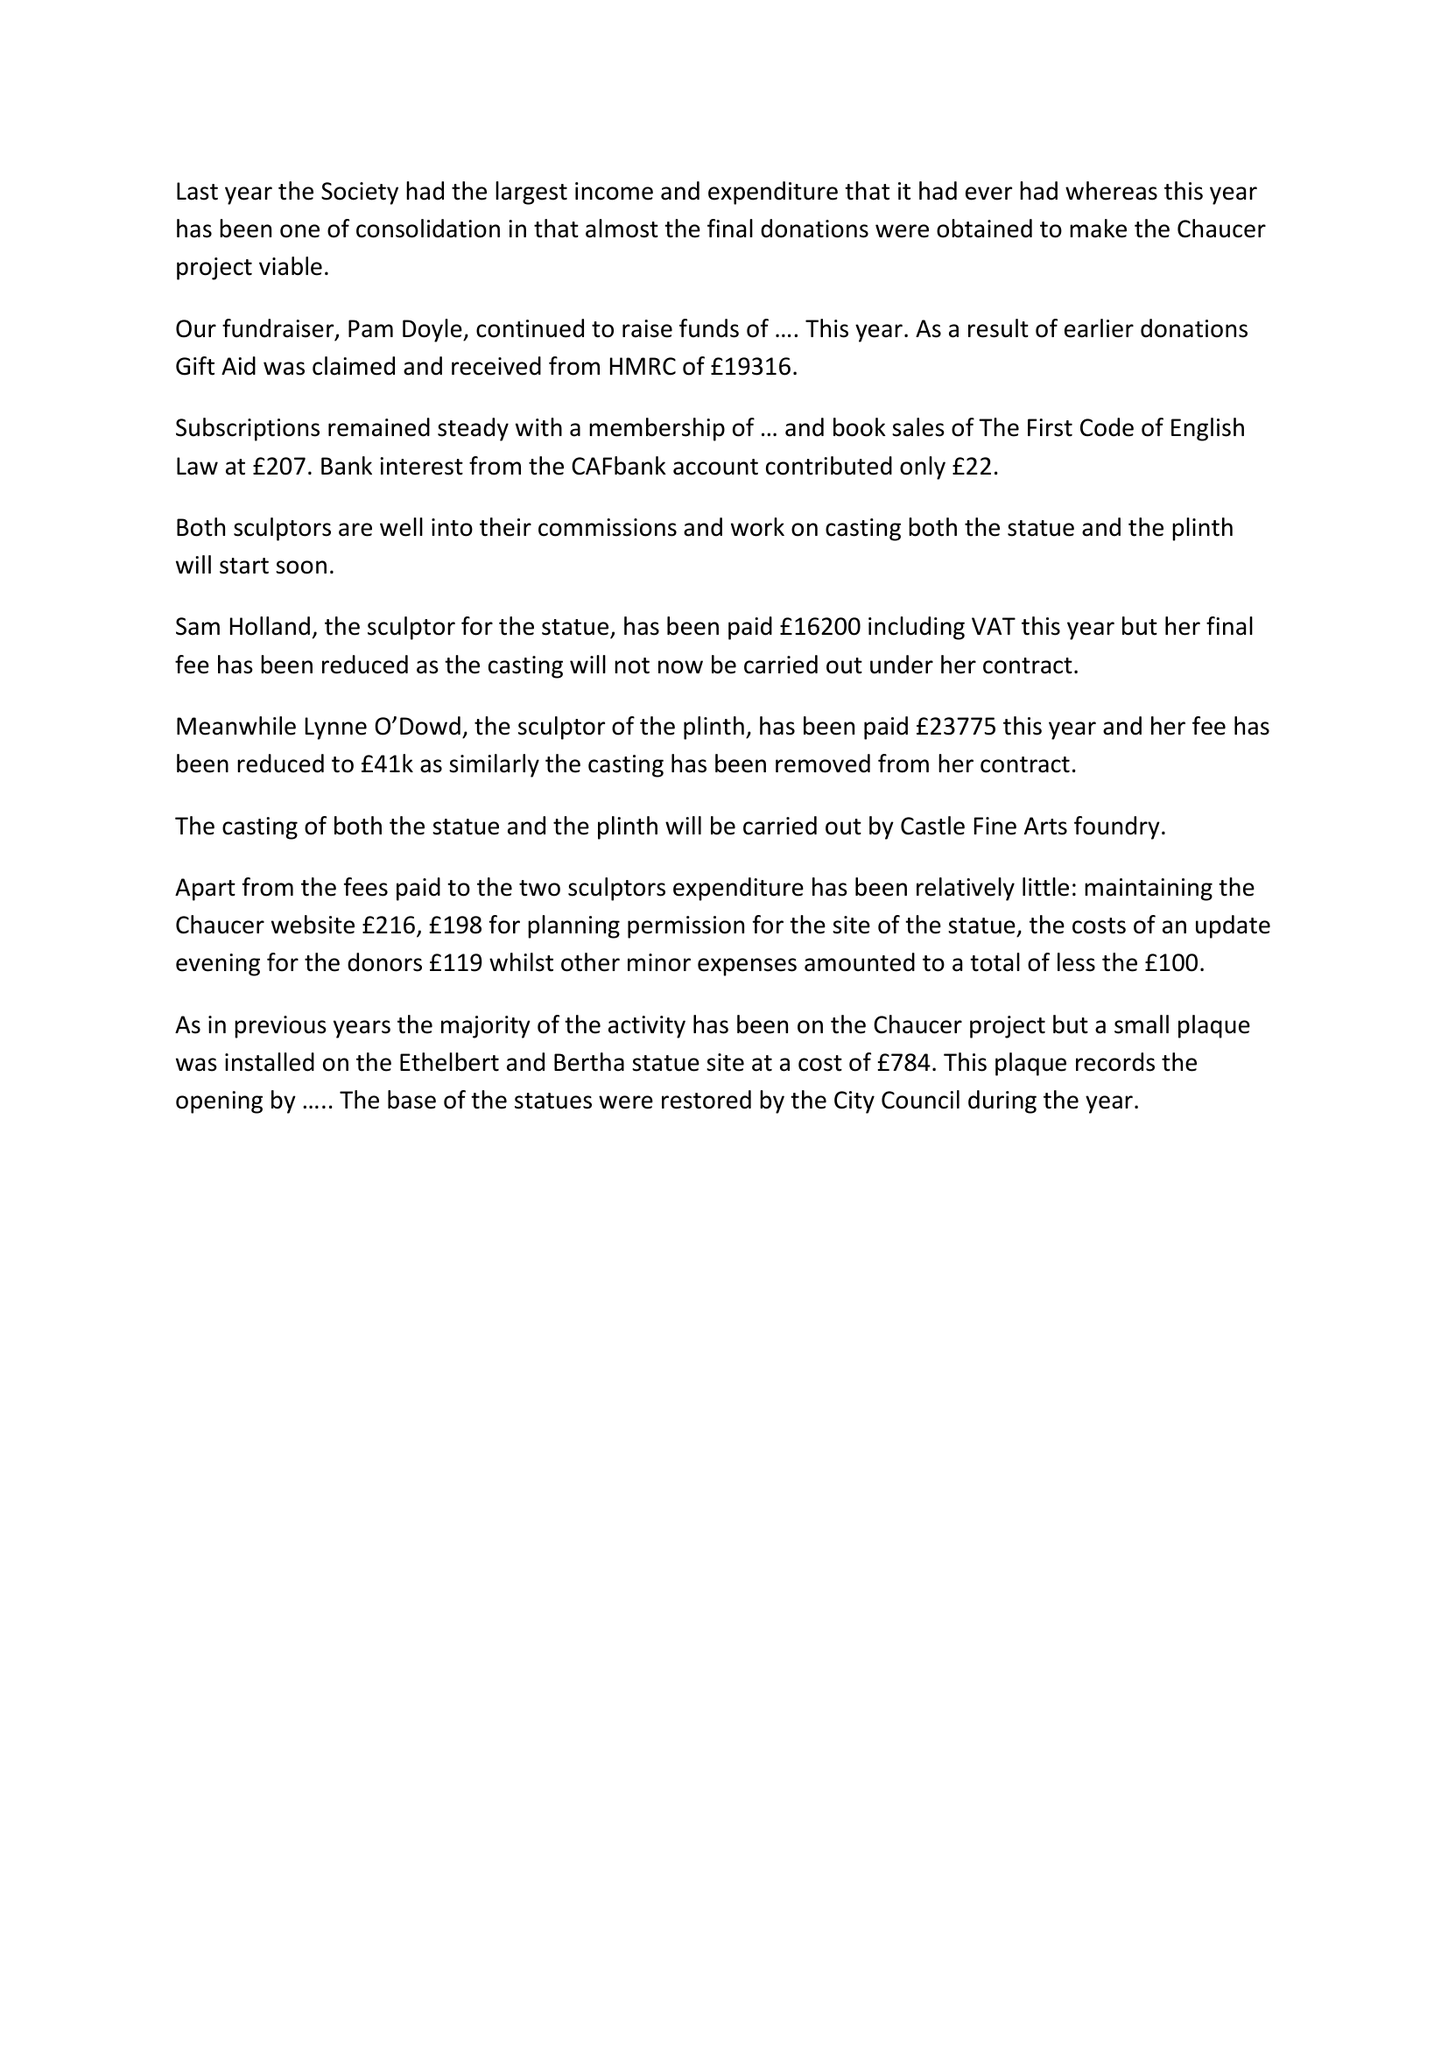What is the value for the spending_annually_in_british_pounds?
Answer the question using a single word or phrase. 43224.00 